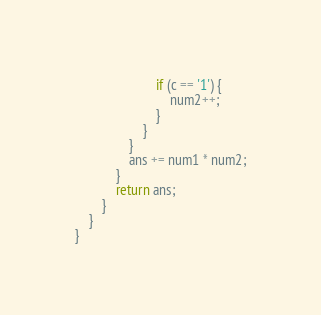<code> <loc_0><loc_0><loc_500><loc_500><_Java_>                        if (c == '1') {
                            num2++;
                        }
                    }
                }
                ans += num1 * num2;
            }
            return ans;
        }
    }
}
</code> 